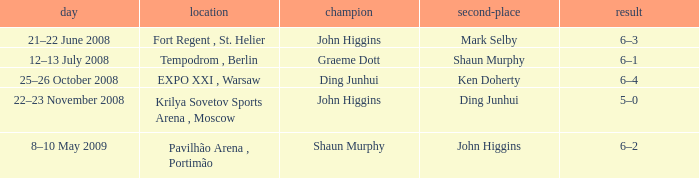Who was the winner in the match that had John Higgins as runner-up? Shaun Murphy. Could you parse the entire table? {'header': ['day', 'location', 'champion', 'second-place', 'result'], 'rows': [['21–22 June 2008', 'Fort Regent , St. Helier', 'John Higgins', 'Mark Selby', '6–3'], ['12–13 July 2008', 'Tempodrom , Berlin', 'Graeme Dott', 'Shaun Murphy', '6–1'], ['25–26 October 2008', 'EXPO XXI , Warsaw', 'Ding Junhui', 'Ken Doherty', '6–4'], ['22–23 November 2008', 'Krilya Sovetov Sports Arena , Moscow', 'John Higgins', 'Ding Junhui', '5–0'], ['8–10 May 2009', 'Pavilhão Arena , Portimão', 'Shaun Murphy', 'John Higgins', '6–2']]} 